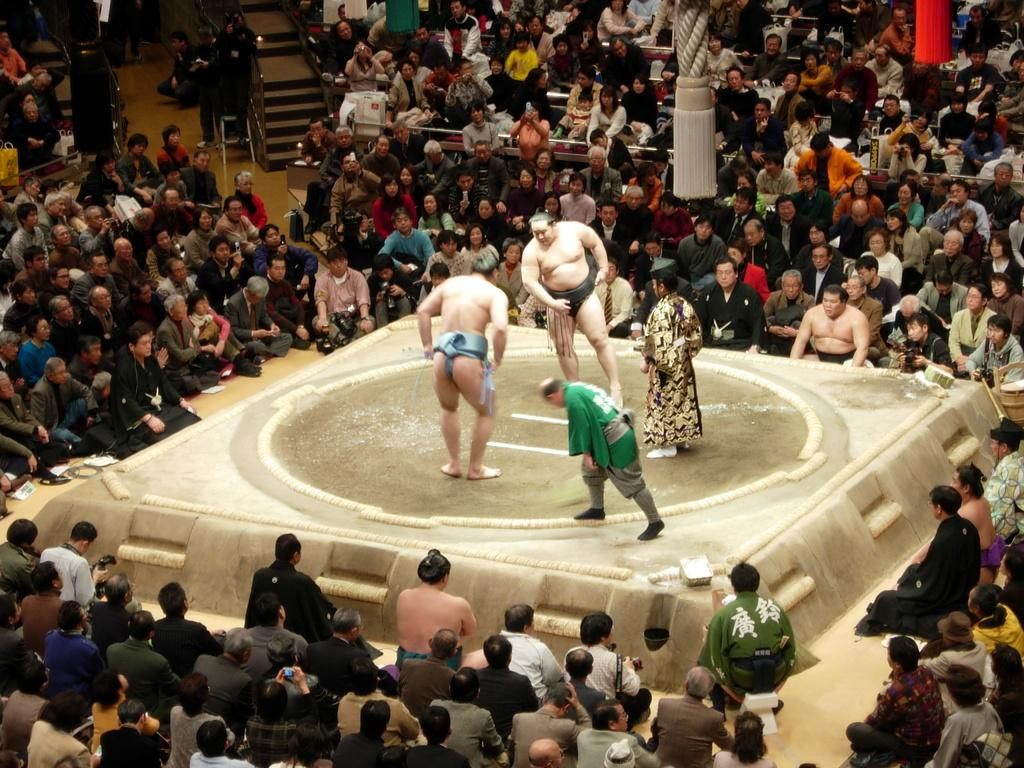What is the main subject in the center of the image? There is a sumo in the center of the image. What is the shape of the sumo? The sumo is a circular ring. What are the two persons in the sumo ring doing? They are fighting in the sumo ring. Who is watching the sumo wrestling match? There are spectators around the sumo ring. What type of produce is being sold at the border in the image? There is no produce or border present in the image; it features a sumo ring with two persons fighting and spectators watching. 